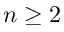Convert formula to latex. <formula><loc_0><loc_0><loc_500><loc_500>n \geq 2</formula> 